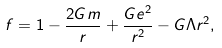<formula> <loc_0><loc_0><loc_500><loc_500>f = 1 - \frac { 2 G m } { r } + \frac { G e ^ { 2 } } { r ^ { 2 } } - G \Lambda r ^ { 2 } ,</formula> 